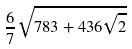Convert formula to latex. <formula><loc_0><loc_0><loc_500><loc_500>\frac { 6 } { 7 } \sqrt { 7 8 3 + 4 3 6 \sqrt { 2 } }</formula> 